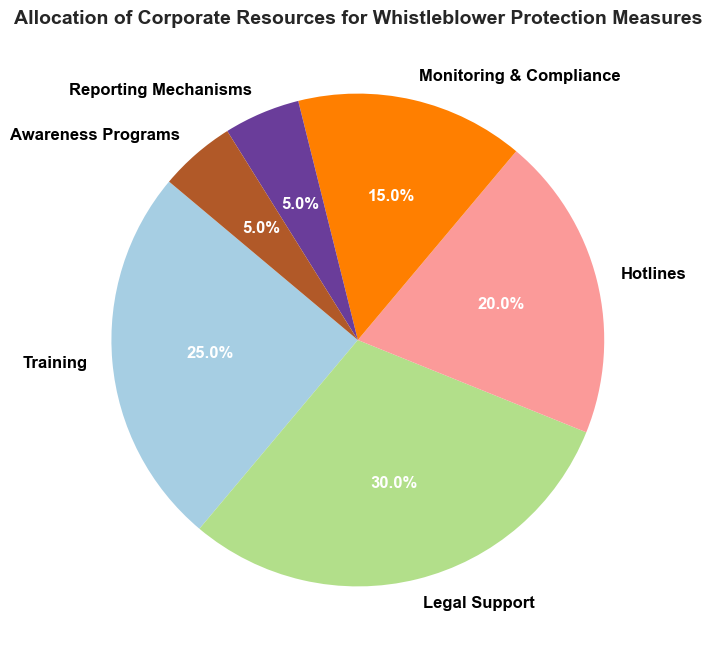What percentage of resources is allocated to hotlines? Locate the section labeled "Hotlines" on the pie chart and read the corresponding percentage value.
Answer: 20% Which category has the smallest allocation of resources? Identify the section of the pie chart with the smallest slice and read the label.
Answer: Reporting Mechanisms and Awareness Programs Which categories combined take up more resources than Legal Support? Legal Support accounts for 30%. Adding up the percentages for categories to find which totals are greater than 30% results in Training (25%) + Hotlines (20%) = 45%, and Training (25%) + Monitoring & Compliance (15%) = 40%.
Answer: Training and Hotlines; Training and Monitoring & Compliance What is the difference in resource allocation between Training and Legal Support? Subtract the percentage allocated to Training from the percentage allocated to Legal Support. 30% - 25% = 5%.
Answer: 5% Which category uses more resources: Monitoring & Compliance or Reporting Mechanisms and Awareness Programs combined? Monitoring & Compliance is allocated 15%. Reporting Mechanisms and Awareness Programs combined are 5% + 5% = 10%. Therefore, Monitoring & Compliance uses more resources.
Answer: Monitoring & Compliance What is the average percentage allocation for Training, Legal Support, and Hotlines? Sum the percentages for Training (25%), Legal Support (30%), and Hotlines (20%), then divide by the number of categories (3): (25% + 30% + 20%) / 3 = 25%.
Answer: 25% How many categories use less than 10% of the resources each? Count the slices with percentages less than 10%. Reporting Mechanisms and Awareness Programs both have 5%, so 2 categories.
Answer: 2 In terms of allocation, does Training use more resources than Monitoring & Compliance and Reporting Mechanisms combined? Compare the percentage for Training (25%) with the sum of Monitoring & Compliance (15%) and Reporting Mechanisms (5%): 15% + 5% = 20%. 25% is greater than 20%.
Answer: Yes Which category is depicted with the second largest slice in the pie chart? Identify the slice labeled with the second highest percentage after Legal Support (30%). Training is the next at 25%.
Answer: Training 